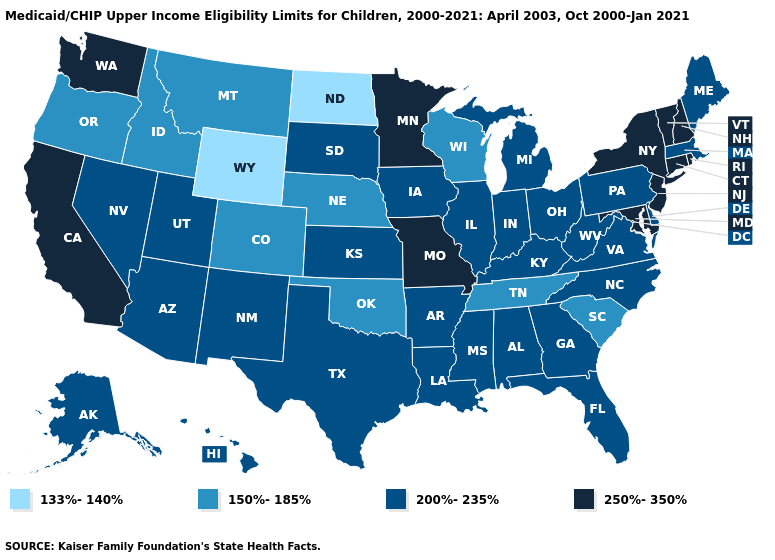What is the lowest value in the South?
Keep it brief. 150%-185%. Name the states that have a value in the range 200%-235%?
Be succinct. Alabama, Alaska, Arizona, Arkansas, Delaware, Florida, Georgia, Hawaii, Illinois, Indiana, Iowa, Kansas, Kentucky, Louisiana, Maine, Massachusetts, Michigan, Mississippi, Nevada, New Mexico, North Carolina, Ohio, Pennsylvania, South Dakota, Texas, Utah, Virginia, West Virginia. How many symbols are there in the legend?
Be succinct. 4. Among the states that border New Jersey , which have the highest value?
Quick response, please. New York. Does the first symbol in the legend represent the smallest category?
Be succinct. Yes. Which states have the lowest value in the USA?
Concise answer only. North Dakota, Wyoming. Does South Carolina have the lowest value in the South?
Write a very short answer. Yes. Does the first symbol in the legend represent the smallest category?
Keep it brief. Yes. What is the lowest value in the USA?
Give a very brief answer. 133%-140%. What is the value of North Dakota?
Keep it brief. 133%-140%. Is the legend a continuous bar?
Keep it brief. No. Name the states that have a value in the range 200%-235%?
Keep it brief. Alabama, Alaska, Arizona, Arkansas, Delaware, Florida, Georgia, Hawaii, Illinois, Indiana, Iowa, Kansas, Kentucky, Louisiana, Maine, Massachusetts, Michigan, Mississippi, Nevada, New Mexico, North Carolina, Ohio, Pennsylvania, South Dakota, Texas, Utah, Virginia, West Virginia. Name the states that have a value in the range 250%-350%?
Write a very short answer. California, Connecticut, Maryland, Minnesota, Missouri, New Hampshire, New Jersey, New York, Rhode Island, Vermont, Washington. What is the value of Colorado?
Give a very brief answer. 150%-185%. What is the highest value in the USA?
Concise answer only. 250%-350%. 